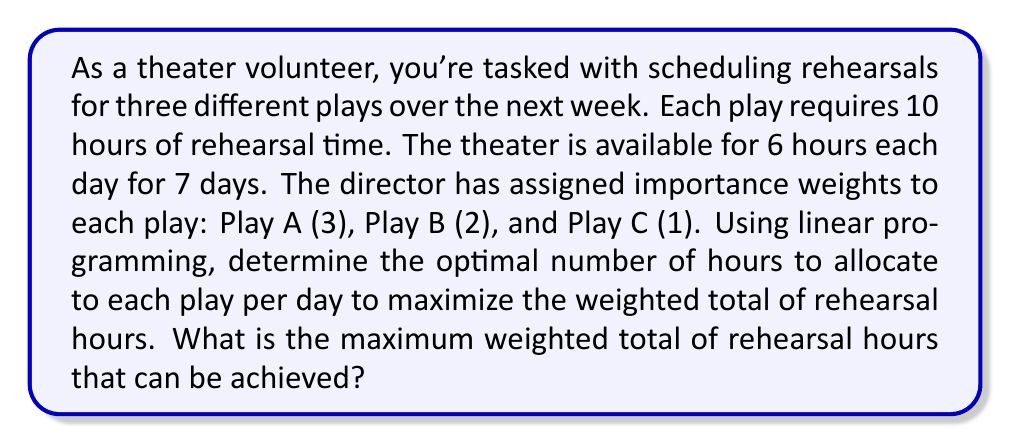Give your solution to this math problem. Let's approach this problem using linear programming:

1) Define variables:
   $x_A$, $x_B$, $x_C$ = daily hours for Play A, B, and C respectively

2) Objective function:
   Maximize $Z = 3x_A + 2x_B + x_C$ (weighted total of daily hours)

3) Constraints:
   $x_A + x_B + x_C \leq 6$ (daily theater availability)
   $7x_A \geq 10$, $7x_B \geq 10$, $7x_C \geq 10$ (minimum rehearsal requirements)
   $x_A, x_B, x_C \geq 0$ (non-negativity)

4) Simplify minimum rehearsal constraints:
   $x_A \geq \frac{10}{7}$, $x_B \geq \frac{10}{7}$, $x_C \geq \frac{10}{7}$

5) Solve using the simplex method or graphical method:
   The optimal solution is:
   $x_A = 3$, $x_B = 2$, $x_C = 1$

6) Calculate the daily weighted total:
   $Z = 3(3) + 2(2) + 1(1) = 9 + 4 + 1 = 14$

7) Multiply by 7 days to get the weekly weighted total:
   $14 * 7 = 98$

Therefore, the maximum weighted total of rehearsal hours that can be achieved over the week is 98.
Answer: 98 weighted rehearsal hours 